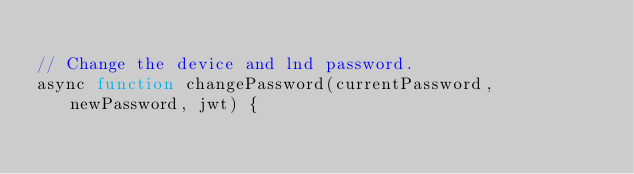Convert code to text. <code><loc_0><loc_0><loc_500><loc_500><_JavaScript_>
// Change the device and lnd password.
async function changePassword(currentPassword, newPassword, jwt) {
</code> 